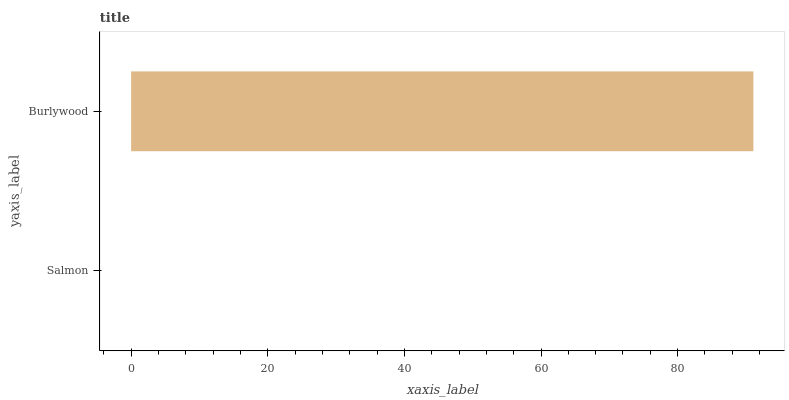Is Salmon the minimum?
Answer yes or no. Yes. Is Burlywood the maximum?
Answer yes or no. Yes. Is Burlywood the minimum?
Answer yes or no. No. Is Burlywood greater than Salmon?
Answer yes or no. Yes. Is Salmon less than Burlywood?
Answer yes or no. Yes. Is Salmon greater than Burlywood?
Answer yes or no. No. Is Burlywood less than Salmon?
Answer yes or no. No. Is Burlywood the high median?
Answer yes or no. Yes. Is Salmon the low median?
Answer yes or no. Yes. Is Salmon the high median?
Answer yes or no. No. Is Burlywood the low median?
Answer yes or no. No. 